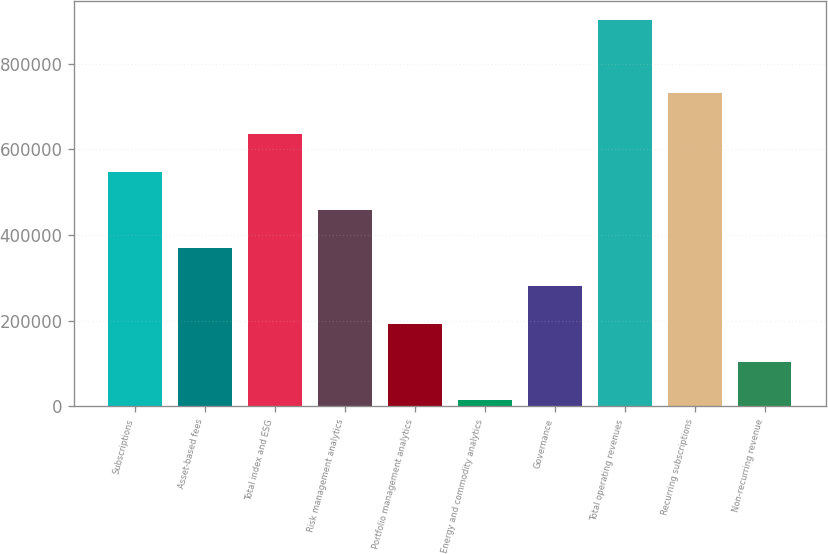Convert chart to OTSL. <chart><loc_0><loc_0><loc_500><loc_500><bar_chart><fcel>Subscriptions<fcel>Asset-based fees<fcel>Total index and ESG<fcel>Risk management analytics<fcel>Portfolio management analytics<fcel>Energy and commodity analytics<fcel>Governance<fcel>Total operating revenues<fcel>Recurring subscriptions<fcel>Non-recurring revenue<nl><fcel>546270<fcel>368934<fcel>634938<fcel>457602<fcel>191599<fcel>14263<fcel>280266<fcel>900941<fcel>732473<fcel>102931<nl></chart> 